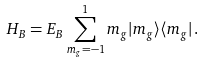<formula> <loc_0><loc_0><loc_500><loc_500>H _ { B } = E _ { B } \sum _ { m _ { g } = - 1 } ^ { 1 } m _ { g } | m _ { g } \rangle \langle m _ { g } | \, .</formula> 